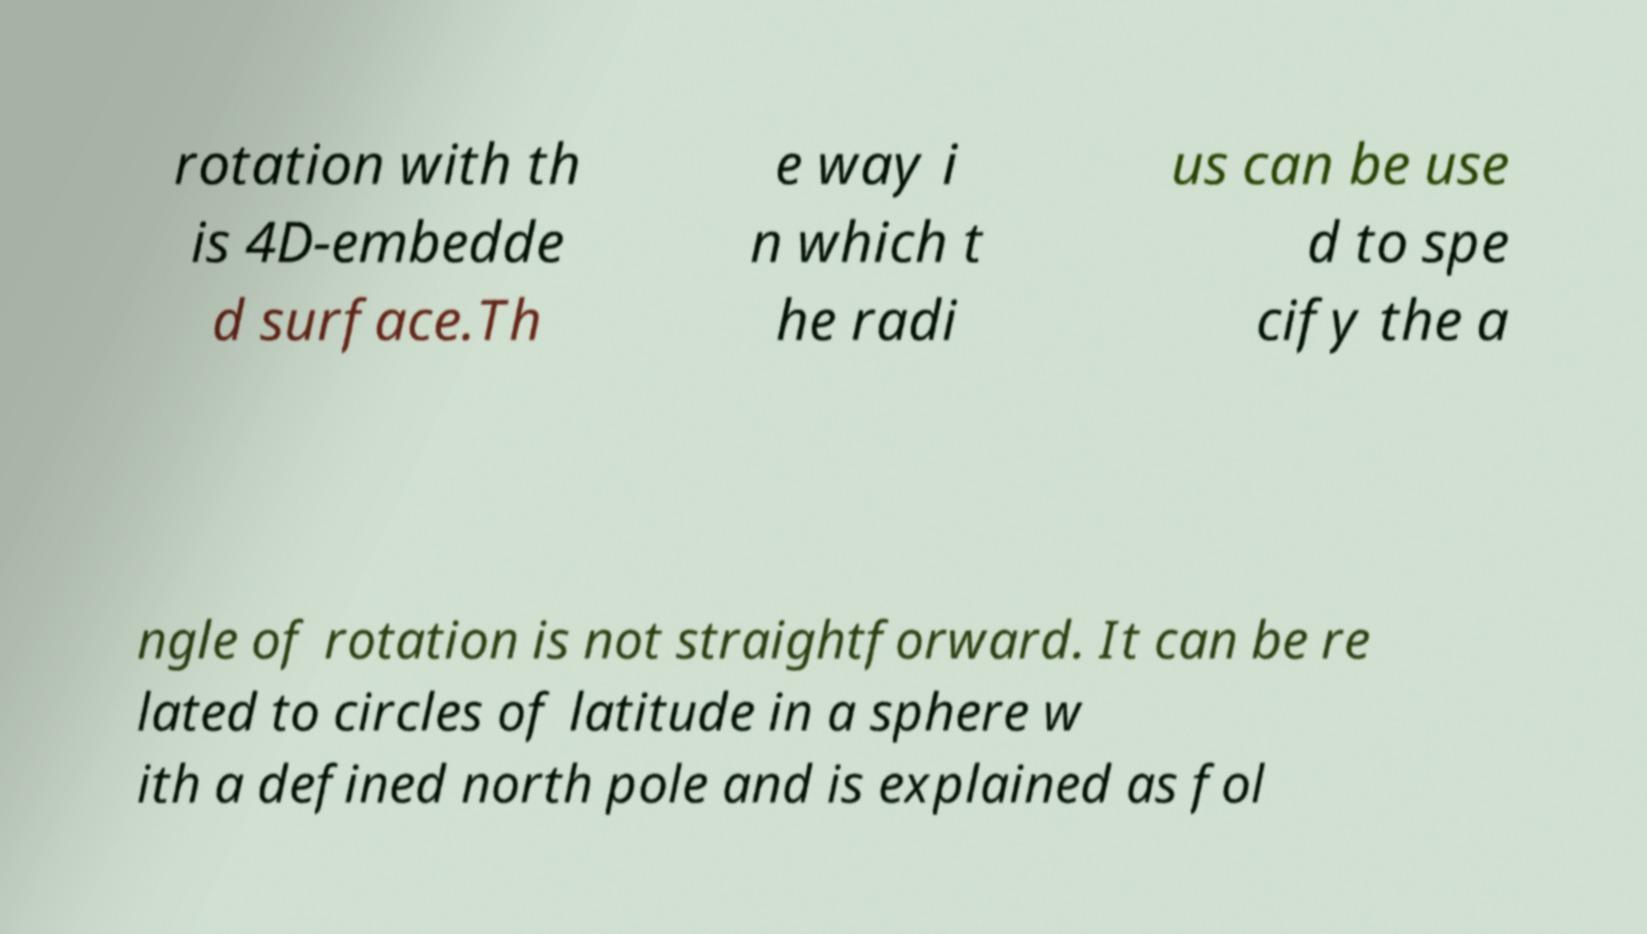Can you accurately transcribe the text from the provided image for me? rotation with th is 4D-embedde d surface.Th e way i n which t he radi us can be use d to spe cify the a ngle of rotation is not straightforward. It can be re lated to circles of latitude in a sphere w ith a defined north pole and is explained as fol 